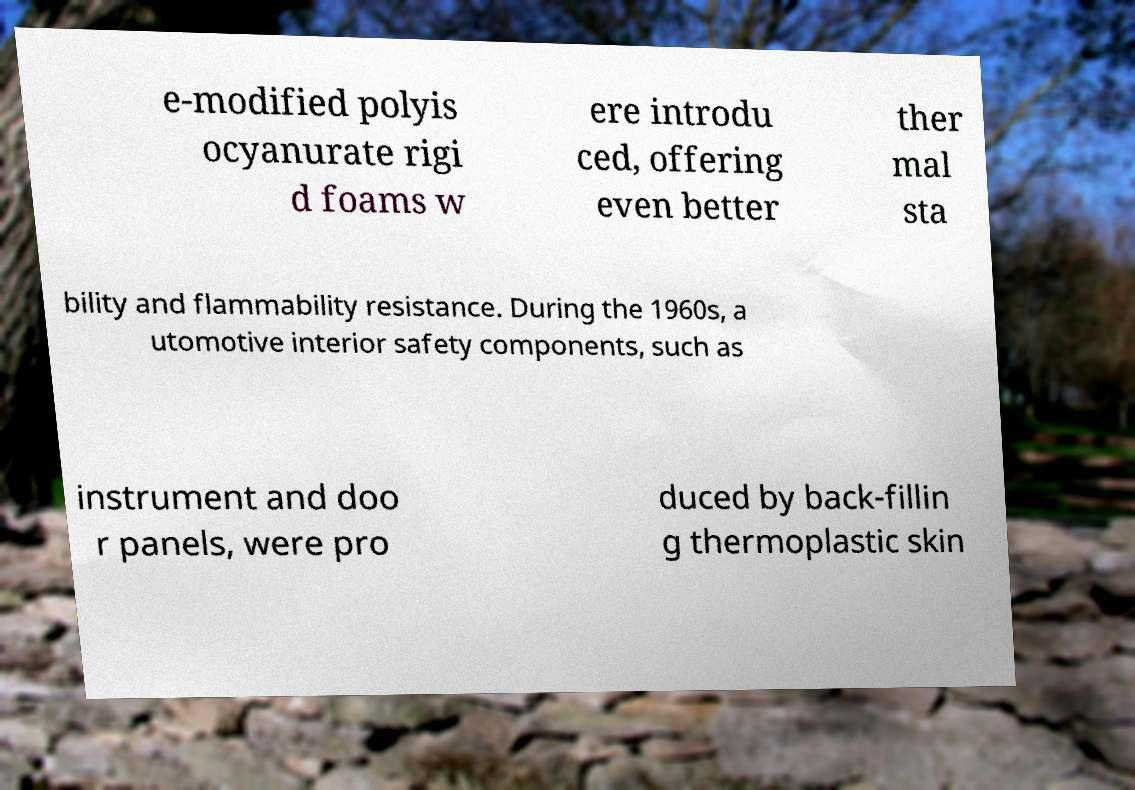There's text embedded in this image that I need extracted. Can you transcribe it verbatim? e-modified polyis ocyanurate rigi d foams w ere introdu ced, offering even better ther mal sta bility and flammability resistance. During the 1960s, a utomotive interior safety components, such as instrument and doo r panels, were pro duced by back-fillin g thermoplastic skin 